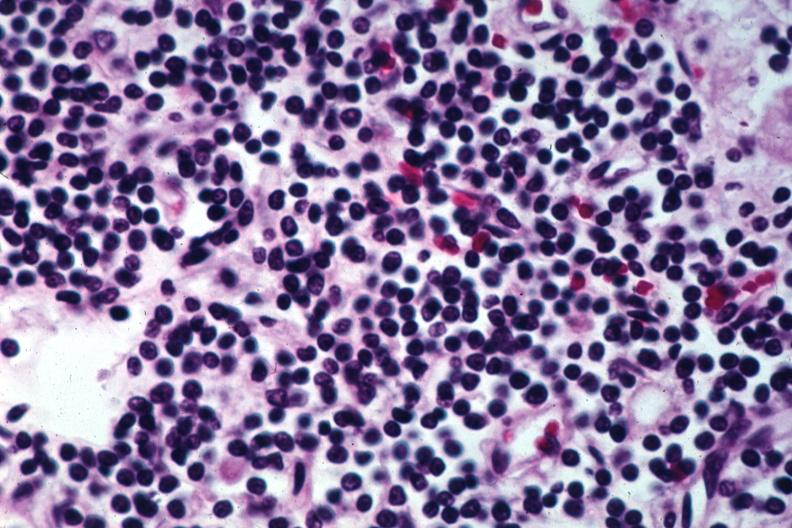does this image show pleomorphic small lymphocytes?
Answer the question using a single word or phrase. Yes 